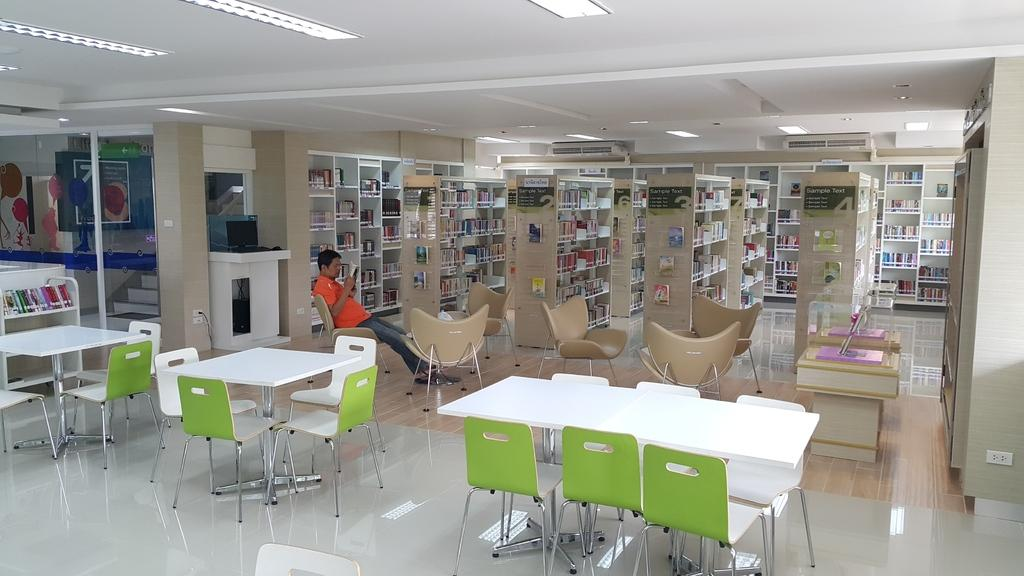What is the man in the image doing? The man is seated and reading a paper in the image. How is the paper being held by the man? The paper is held in the man's hand. What type of furniture can be seen in the image? Chairs, tables, and bookshelves are present in the image. What type of crow can be seen interacting with the man while he reads the paper? There is no crow present in the image; the man is reading a paper without any interaction from a crow. 